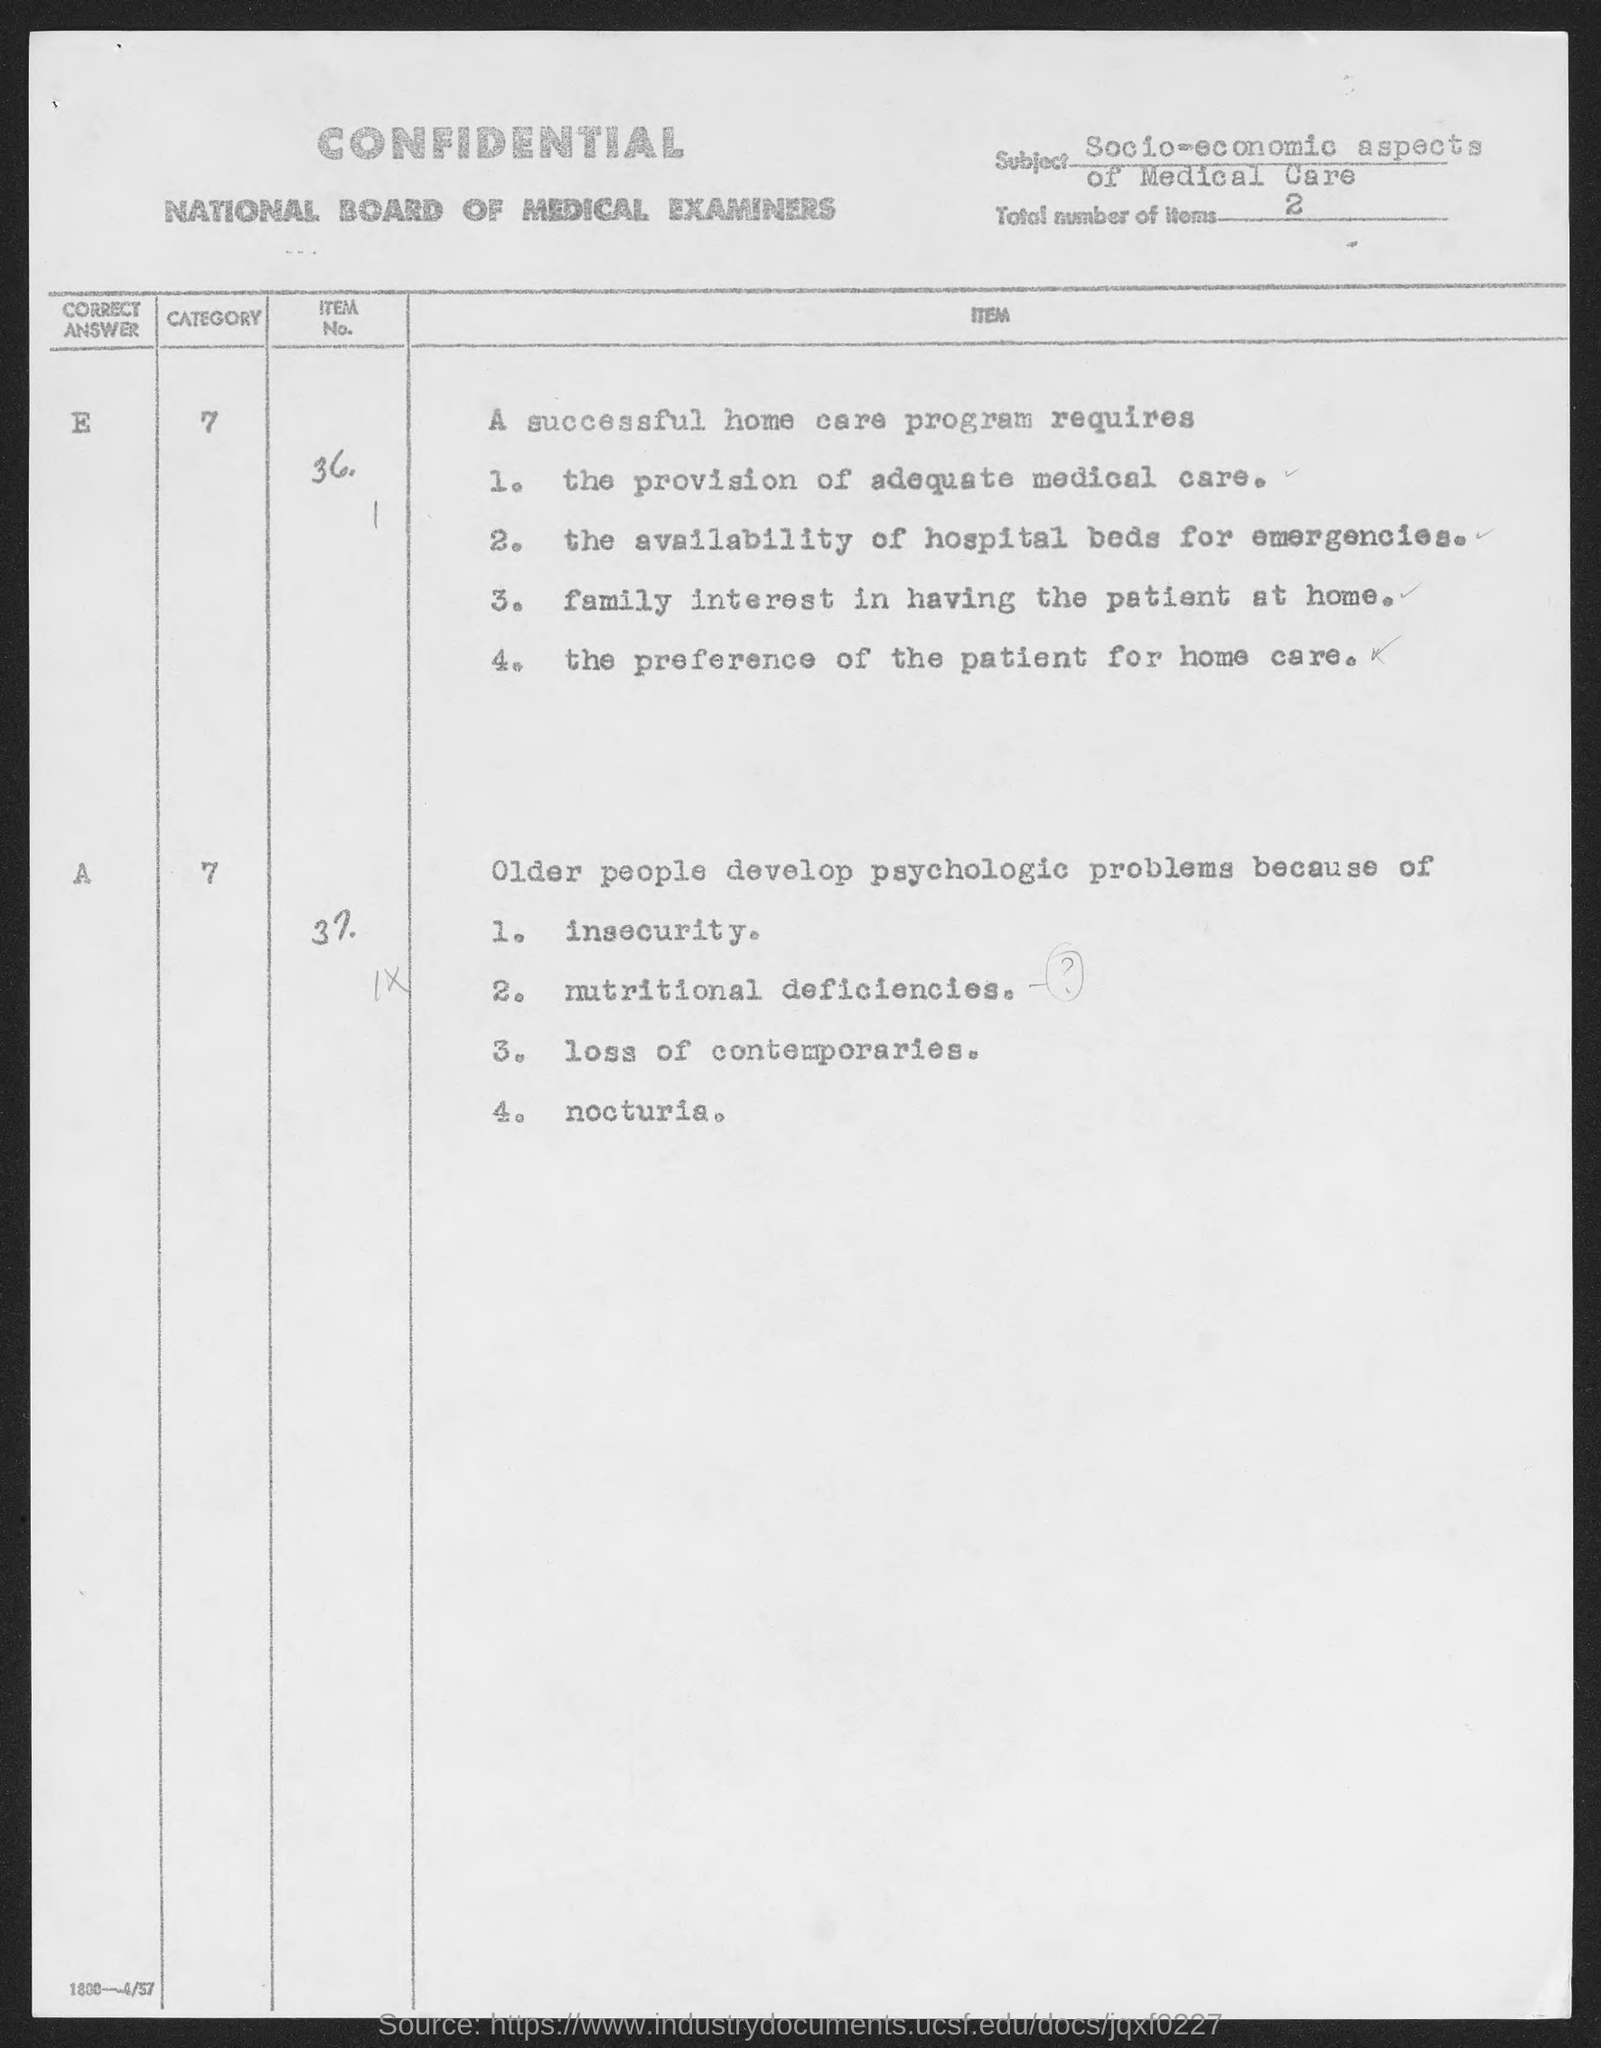Draw attention to some important aspects in this diagram. The total number of items given in the document is 2. 